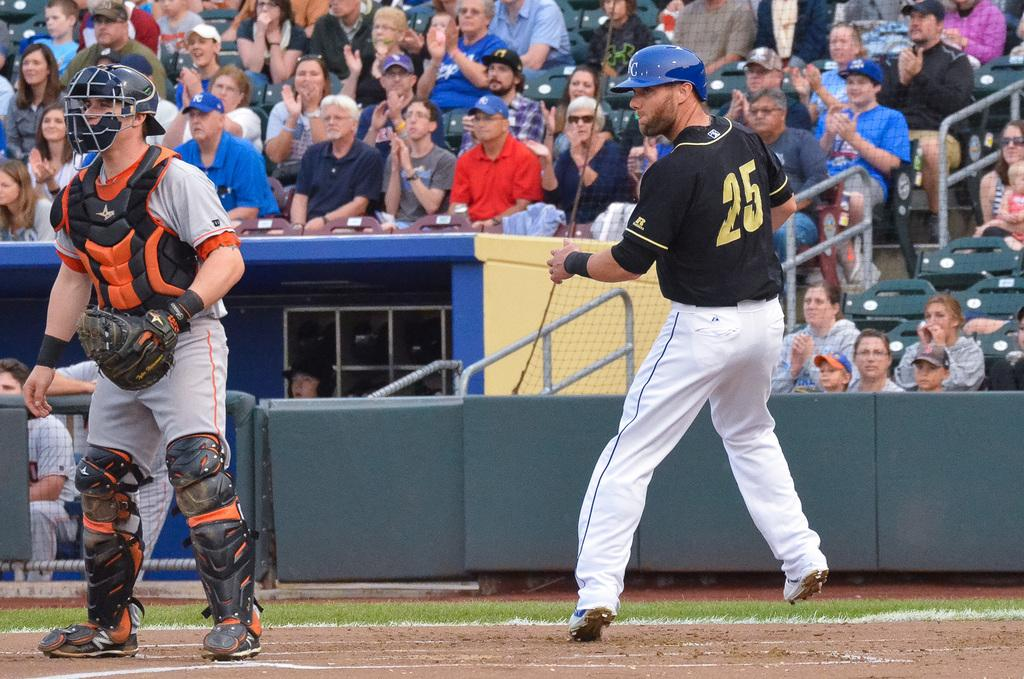<image>
Give a short and clear explanation of the subsequent image. The player batting is wearing the number 25 